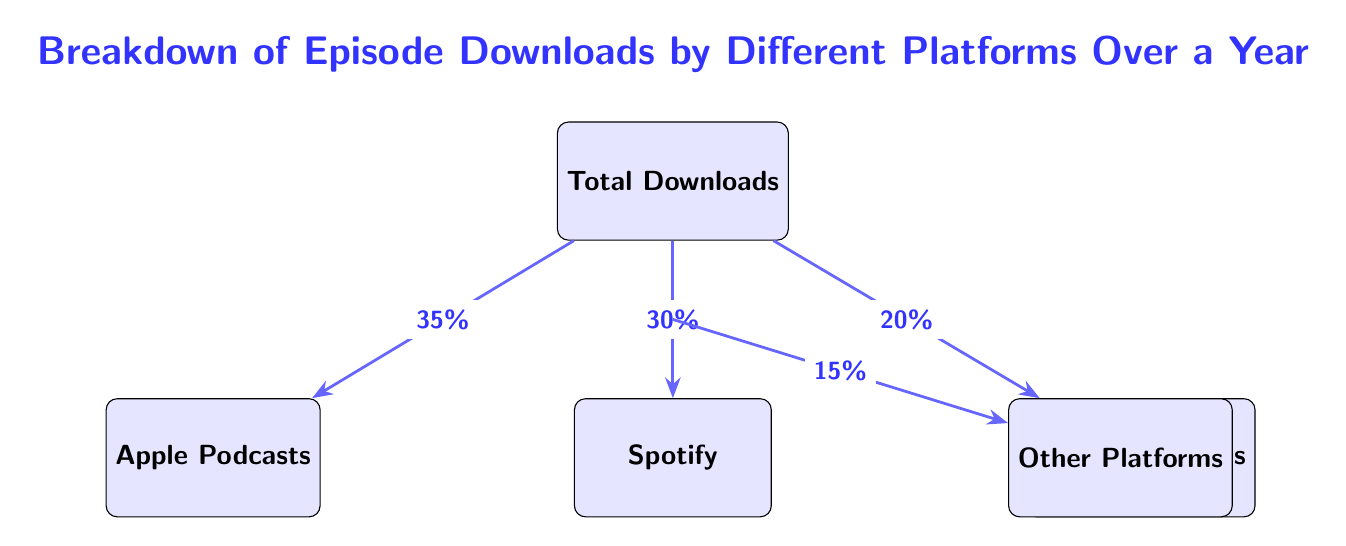What is the percentage of downloads from Apple Podcasts? The diagram indicates that 35% of the total downloads come from Apple Podcasts, which is directly labeled on the arrow connecting Total Downloads to Apple Podcasts.
Answer: 35% How many platforms are mentioned in the diagram? By counting the distinct boxes in the diagram, there are four platforms specified: Apple Podcasts, Spotify, Google Podcasts, and Other Platforms.
Answer: 4 What percentage of downloads comes from Spotify? The arrow connecting Total Downloads to Spotify shows that it accounts for 30% of the downloads. This value is explicitly stated on the diagram.
Answer: 30% Which platform has the least percentage of downloads? Observing the percentages labeled on the arrows, Other Platforms has the least at 15%, as it is the lowest value among the provided percentages.
Answer: Other Platforms What is the combined percentage of downloads for Apple Podcasts and Spotify? To find the combined percentage, you add the percentages for Apple Podcasts (35%) and Spotify (30%). 35% + 30% equals 65%.
Answer: 65% What is the total percentage of downloads accounted for by Google Podcasts and Other Platforms? The diagram shows Google Podcasts at 20% and Other Platforms at 15%. Adding these two together (20% + 15%) gives a total of 35%.
Answer: 35% What is the percentage of downloads from Google Podcasts? The arrow leading from Total Downloads to Google Podcasts indicates that this platform contributes 20% of the total downloads, as labeled on the diagram.
Answer: 20% Which platform contributes the most to episode downloads? By comparing all the percentages labeled on the diagram, Apple Podcasts at 35% represents the highest contribution to episode downloads.
Answer: Apple Podcasts 